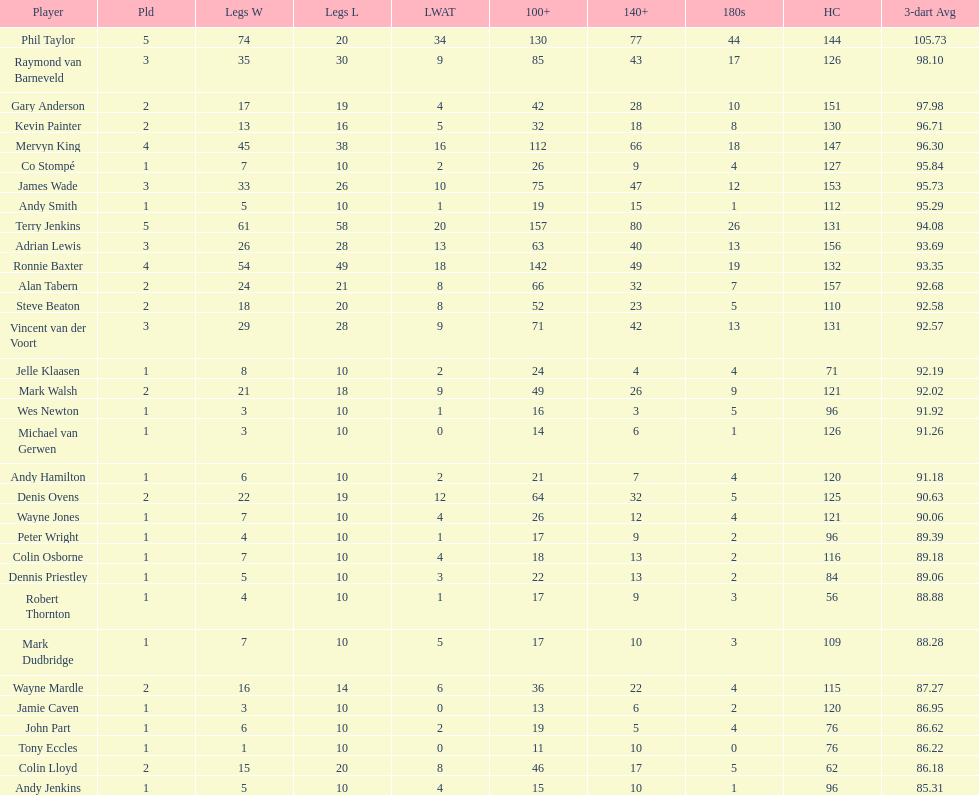How many players in the 2009 world matchplay won at least 30 legs? 6. 